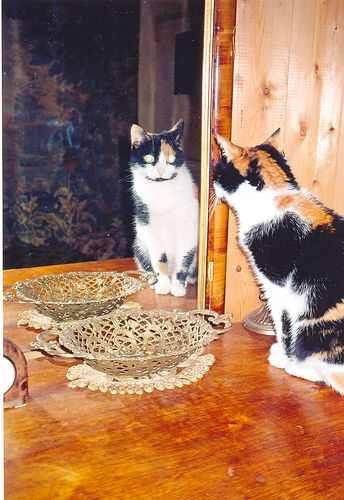Describe the objects in this image and their specific colors. I can see cat in white, black, gray, and tan tones and cat in white, gray, darkgray, and navy tones in this image. 